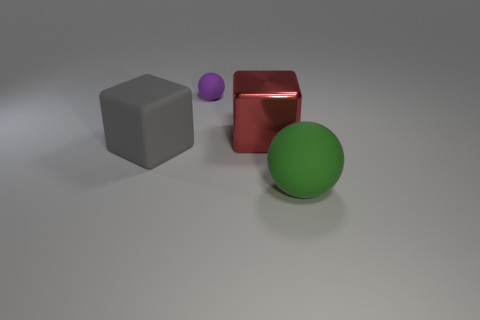What textures are visible on the objects in the image? In the image, we see a variety of textures. The sphere has a smooth and shiny surface, indicating a reflective material, while the cube appears to have a matte finish, diffusing light without reflection. These differing textures add contrast to the scene. 